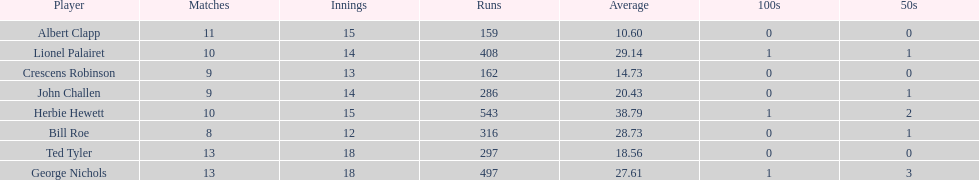How many innings did bill and ted have in total? 30. 